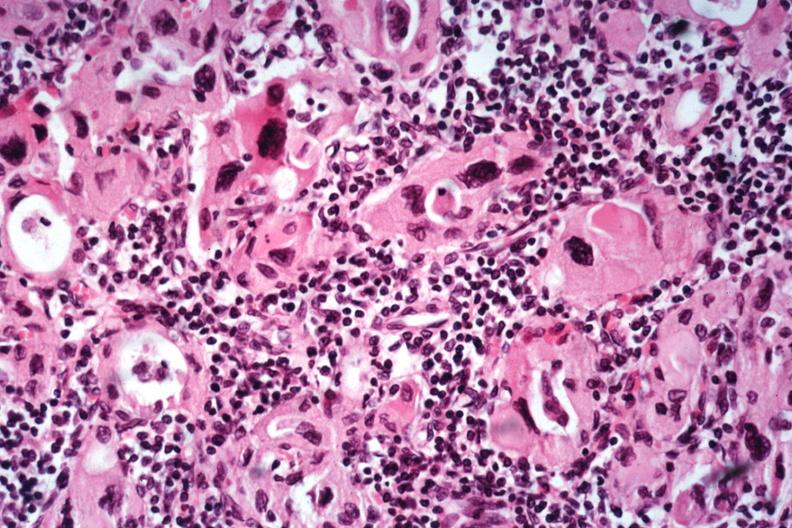what is present?
Answer the question using a single word or phrase. Endocrine 